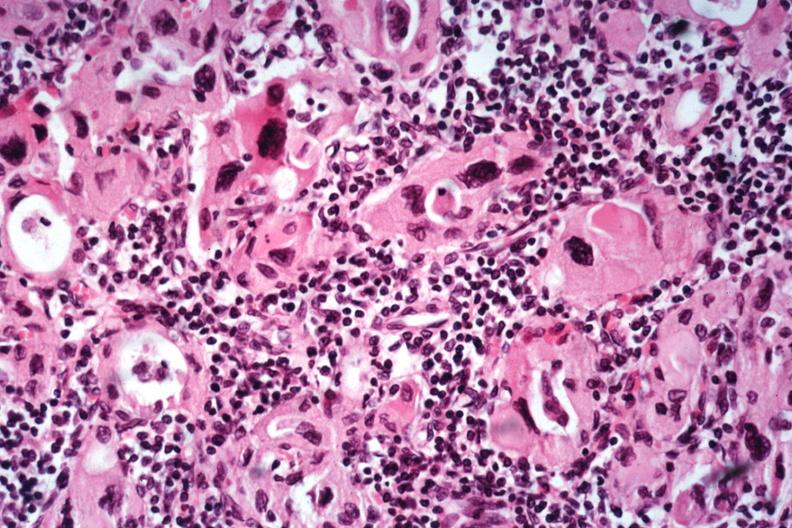what is present?
Answer the question using a single word or phrase. Endocrine 